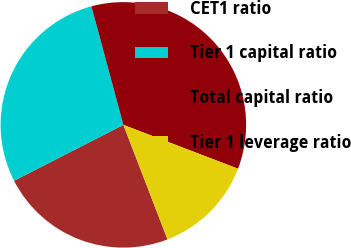Convert chart. <chart><loc_0><loc_0><loc_500><loc_500><pie_chart><fcel>CET1 ratio<fcel>Tier 1 capital ratio<fcel>Total capital ratio<fcel>Tier 1 leverage ratio<nl><fcel>23.33%<fcel>28.33%<fcel>35.0%<fcel>13.33%<nl></chart> 